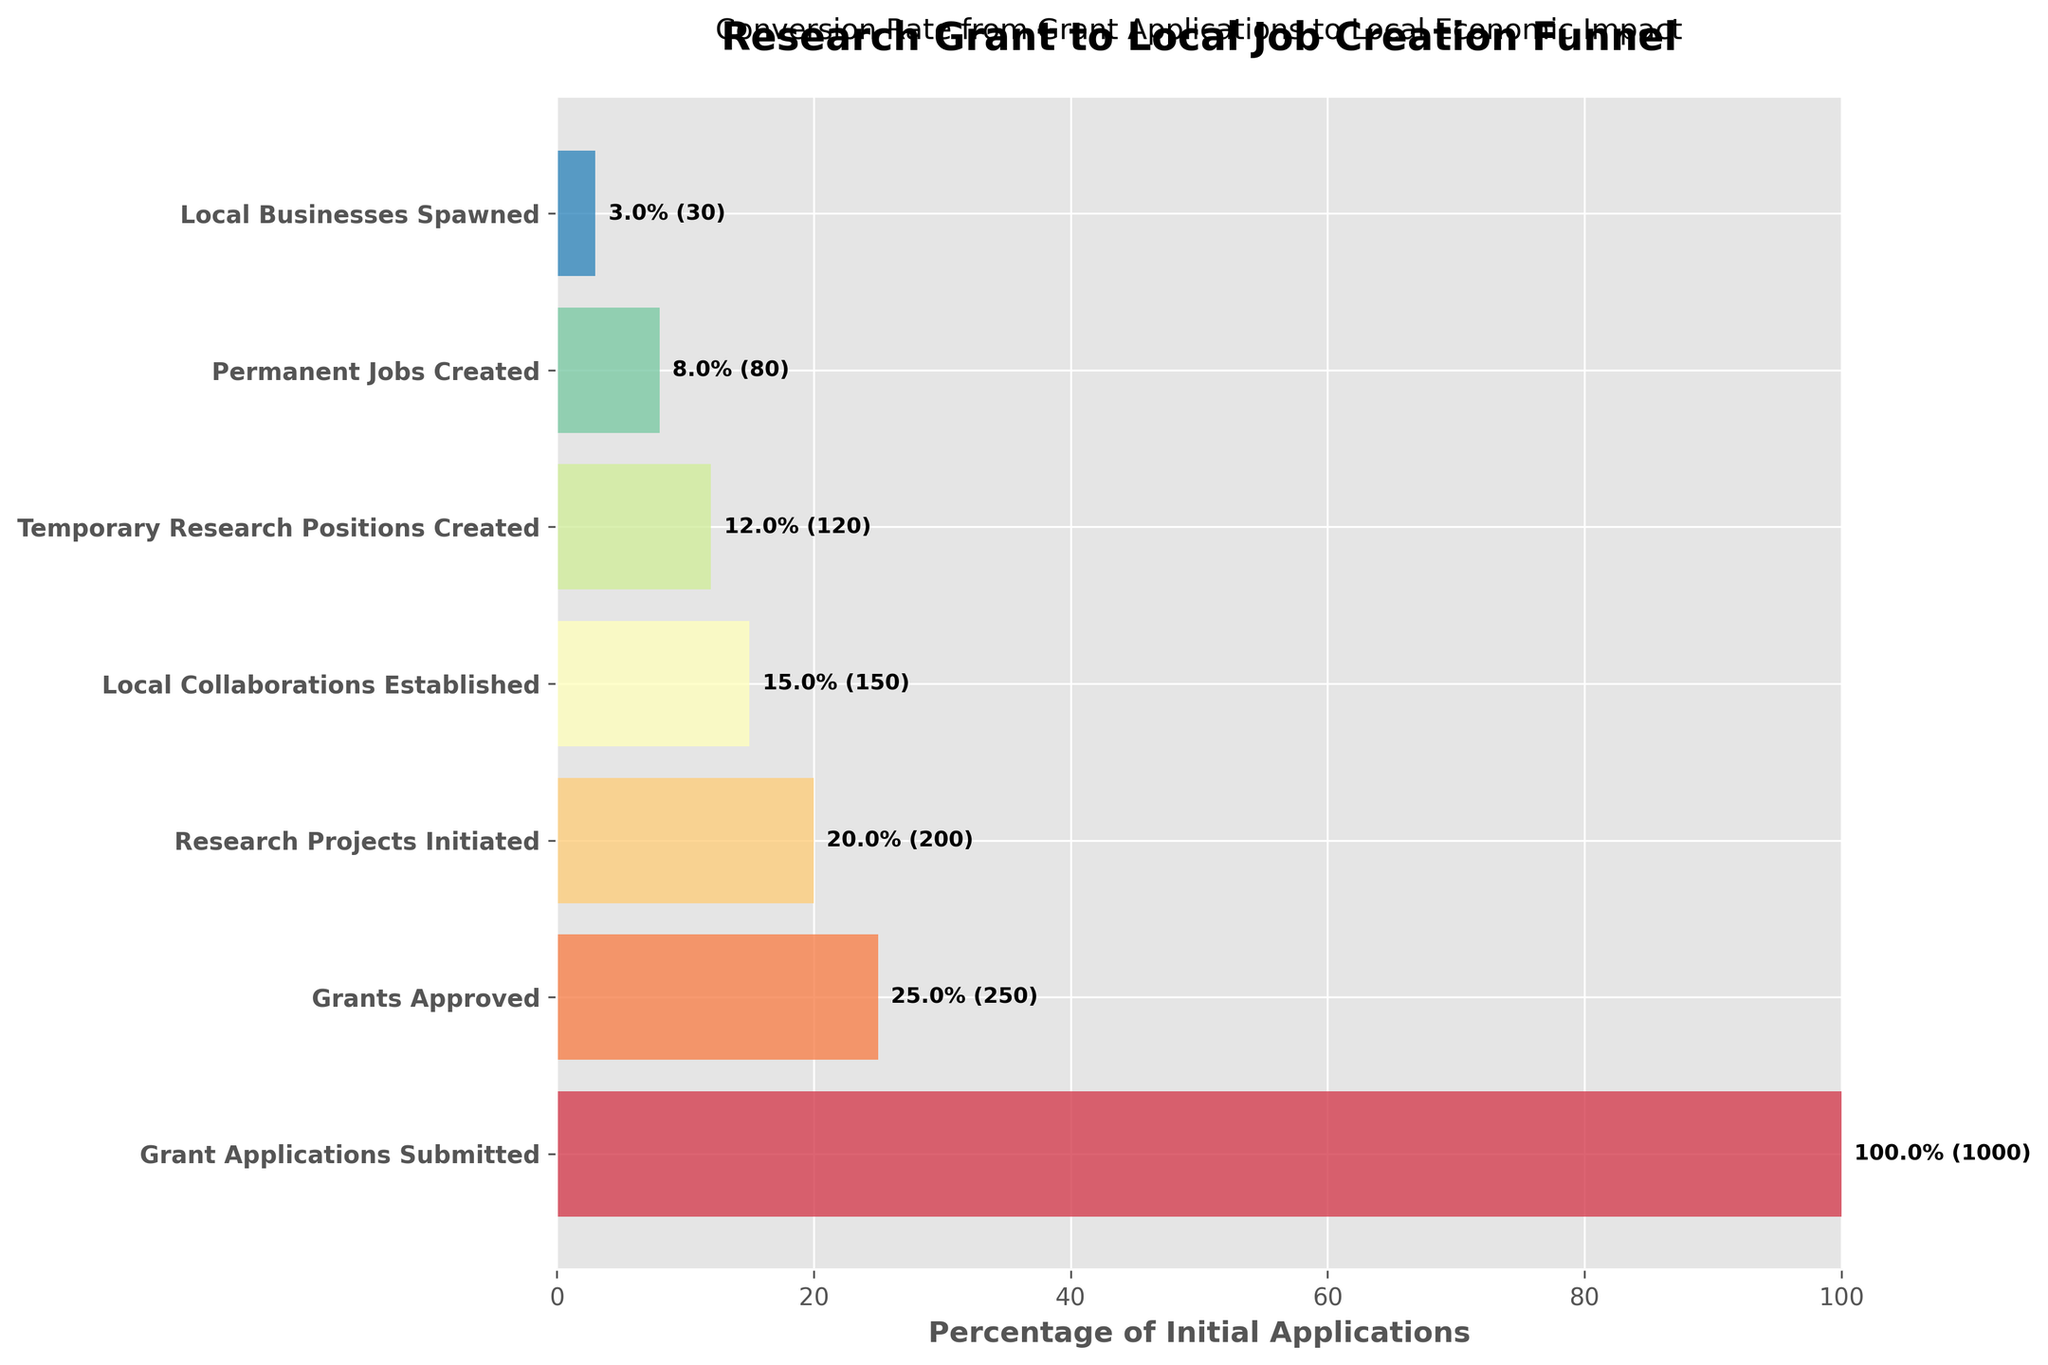what is the title of the figure? The title is usually placed at the top of the figure, and it provides an overview of the content of the chart. By looking at the top of the figure, we can see the text that describes the chart.
Answer: "Research Grant to Local Job Creation Funnel" What percentage of grant applications were approved? To determine this percentage, divide the number of grants approved (250) by the number of grant applications submitted (1000) and then multiply by 100.
Answer: 25% How many stages are represented in the funnel chart? By counting the number of distinct stages listed on the y-axis of the funnel chart, we can determine the number of stages in the process. In this case, the stages are: Grant Applications Submitted, Grants Approved, Research Projects Initiated, Local Collaborations Established, Temporary Research Positions Created, Permanent Jobs Created, Local Businesses Spawned.
Answer: 7 Which stage shows the largest drop in the number of entries? By comparing the difference in values between consecutive stages, we see the largest drop occurs from Grant Applications Submitted (1000) to Grants Approved (250). The difference is the largest at this point.
Answer: From "Grant Applications Submitted" to "Grants Approved" What stage has the highest percentage relative to initial applications? By examining the percentages labeled on the bars within the figure, we identify the stage with the highest percentage relative to the initial submissions. The first stage, "Grant Applications Submitted," is always 100% because it is the base reference.
Answer: "Grant Applications Submitted" How many permanent jobs were created from the research grants? By looking at the bar labeled "Permanent Jobs Created" on the y-axis, we can find the corresponding value for this stage.
Answer: 80 What is the percentage of research projects that advanced to local collaborations established? To find the percentage, divide the number of local collaborations established (150) by the number of research projects initiated (200) and then multiply by 100.
Answer: 75% Compare the number of temporary research positions created and permanent jobs created. Which is higher and by how much? Temporary research positions created: 120. Permanent jobs created: 80. Subtract the number of permanent jobs from temporary positions: 120 - 80.
Answer: Temporary positions by 40 What percentage of grant applications resulted in local businesses being spawned? To determine this, divide the number of local businesses spawned (30) by the total number of grant applications submitted (1000) and then multiply by 100.
Answer: 3% How many more grants were approved than research projects initiated? To find the difference, subtract the number of research projects initiated (200) from the number of grants approved (250).
Answer: 50 